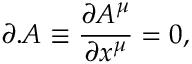<formula> <loc_0><loc_0><loc_500><loc_500>\partial . A \equiv \frac { \partial A ^ { \mu } } { \partial x ^ { \mu } } = 0 ,</formula> 